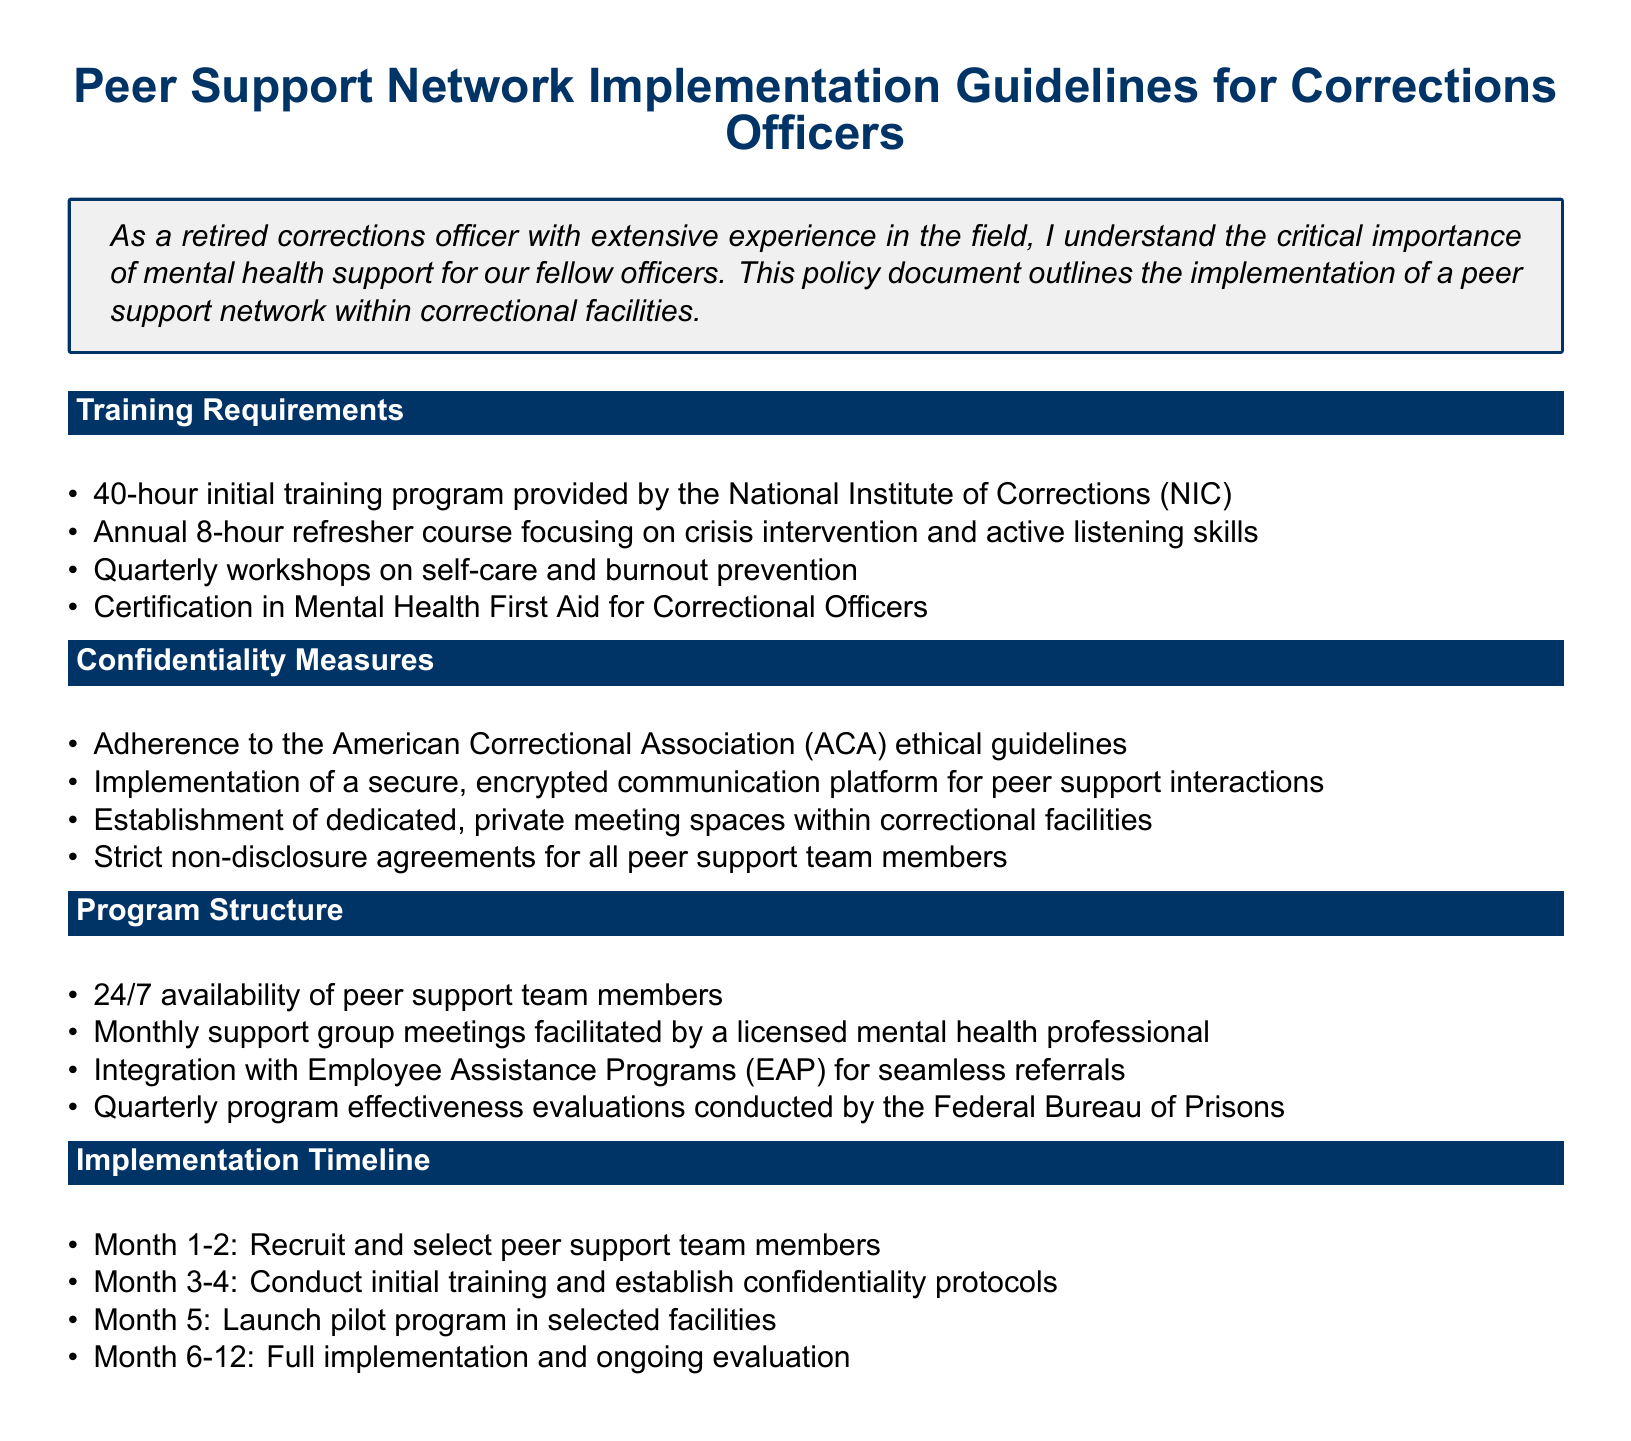What is the duration of the initial training program? The initial training program lasts for 40 hours as specified in the training requirements section.
Answer: 40 hours How often are refresher courses conducted? Refresher courses are conducted annually, as mentioned in the training requirements.
Answer: Annually What certification is required for correctional officers? The document states that certification in Mental Health First Aid for Correctional Officers is required.
Answer: Mental Health First Aid Which organization provides the initial training program? The National Institute of Corrections (NIC) is responsible for providing the initial training program.
Answer: National Institute of Corrections What is the focus of the quarterly workshops? The quarterly workshops focus on self-care and burnout prevention as highlighted in the training requirements.
Answer: Self-care and burnout prevention How many peer support team members are available at any time? The peer support team members are available 24/7 according to the program structure.
Answer: 24/7 What type of meetings are held monthly for peer support? Monthly support group meetings are facilitated by a licensed mental health professional, as outlined in the program structure.
Answer: Support group meetings What is the evaluation frequency of the program's effectiveness? The program effectiveness evaluations are conducted quarterly, as per the program structure.
Answer: Quarterly What ethical guidelines are adhered to in the confidentiality measures? The document specifies adherence to American Correctional Association (ACA) ethical guidelines for confidentiality.
Answer: American Correctional Association 